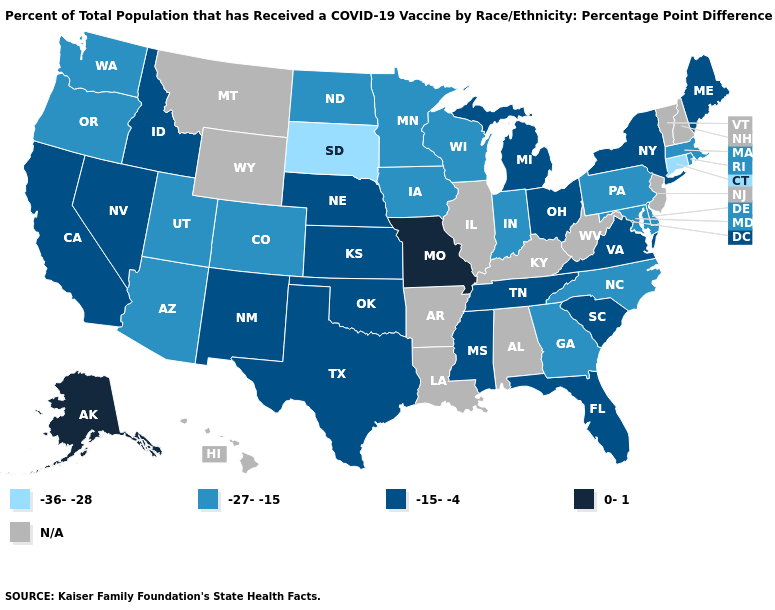How many symbols are there in the legend?
Answer briefly. 5. Name the states that have a value in the range 0-1?
Keep it brief. Alaska, Missouri. What is the value of Illinois?
Give a very brief answer. N/A. What is the value of Nebraska?
Concise answer only. -15--4. Does the map have missing data?
Concise answer only. Yes. Among the states that border New Hampshire , which have the lowest value?
Write a very short answer. Massachusetts. What is the highest value in the USA?
Write a very short answer. 0-1. What is the value of Illinois?
Concise answer only. N/A. Which states have the lowest value in the USA?
Answer briefly. Connecticut, South Dakota. What is the value of Tennessee?
Be succinct. -15--4. What is the highest value in the USA?
Write a very short answer. 0-1. Name the states that have a value in the range -27--15?
Short answer required. Arizona, Colorado, Delaware, Georgia, Indiana, Iowa, Maryland, Massachusetts, Minnesota, North Carolina, North Dakota, Oregon, Pennsylvania, Rhode Island, Utah, Washington, Wisconsin. What is the value of Missouri?
Answer briefly. 0-1. Does the map have missing data?
Quick response, please. Yes. Among the states that border Delaware , which have the highest value?
Give a very brief answer. Maryland, Pennsylvania. 